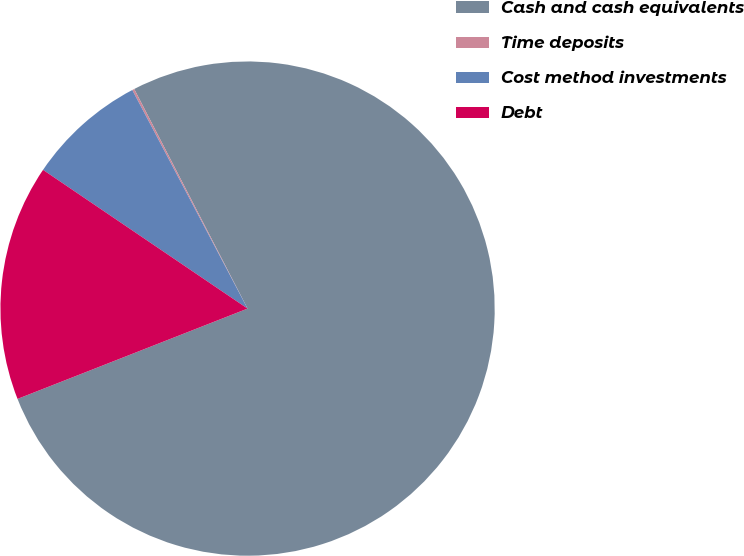Convert chart. <chart><loc_0><loc_0><loc_500><loc_500><pie_chart><fcel>Cash and cash equivalents<fcel>Time deposits<fcel>Cost method investments<fcel>Debt<nl><fcel>76.63%<fcel>0.14%<fcel>7.79%<fcel>15.44%<nl></chart> 